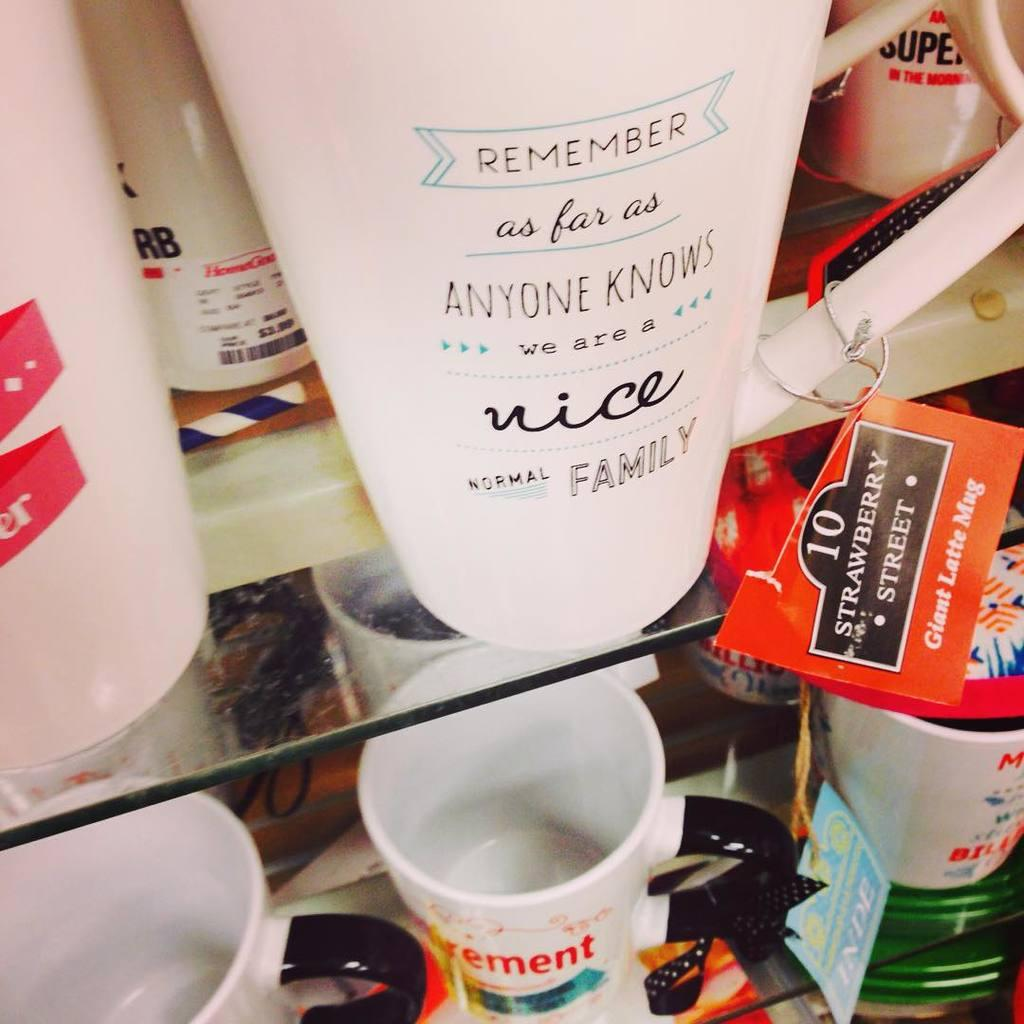<image>
Write a terse but informative summary of the picture. White cups for sale including one that says "Remember". 